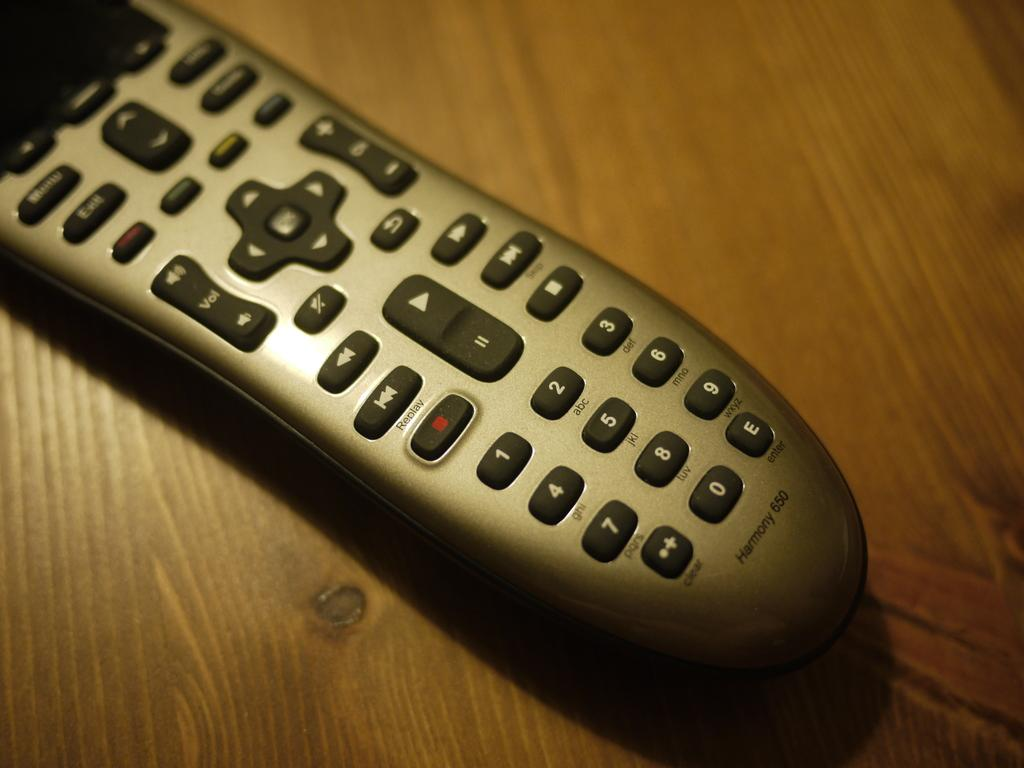Provide a one-sentence caption for the provided image. a remote control with the vol button on it. 